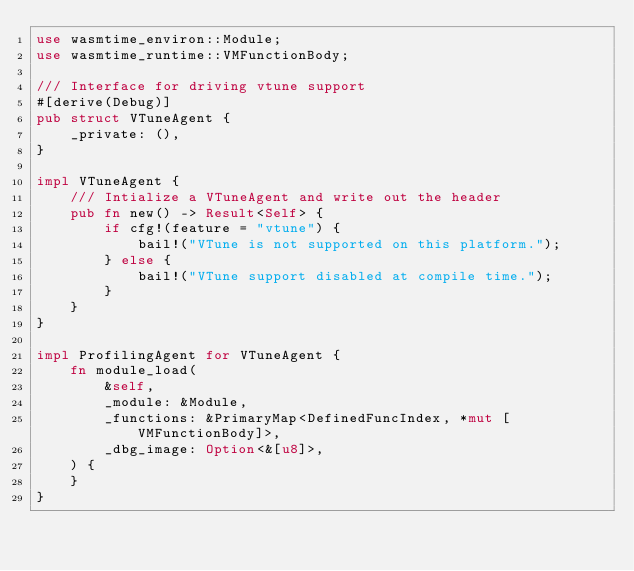<code> <loc_0><loc_0><loc_500><loc_500><_Rust_>use wasmtime_environ::Module;
use wasmtime_runtime::VMFunctionBody;

/// Interface for driving vtune support
#[derive(Debug)]
pub struct VTuneAgent {
    _private: (),
}

impl VTuneAgent {
    /// Intialize a VTuneAgent and write out the header
    pub fn new() -> Result<Self> {
        if cfg!(feature = "vtune") {
            bail!("VTune is not supported on this platform.");
        } else {
            bail!("VTune support disabled at compile time.");
        }
    }
}

impl ProfilingAgent for VTuneAgent {
    fn module_load(
        &self,
        _module: &Module,
        _functions: &PrimaryMap<DefinedFuncIndex, *mut [VMFunctionBody]>,
        _dbg_image: Option<&[u8]>,
    ) {
    }
}
</code> 